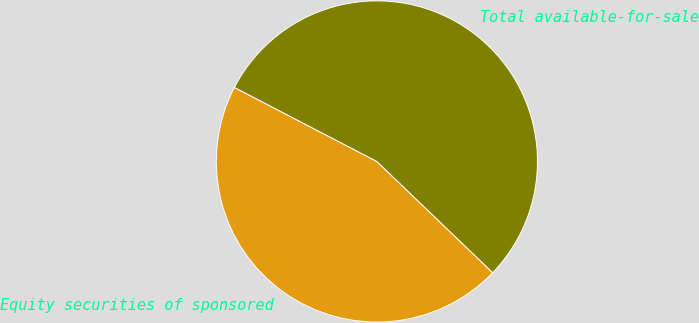<chart> <loc_0><loc_0><loc_500><loc_500><pie_chart><fcel>Equity securities of sponsored<fcel>Total available-for-sale<nl><fcel>45.45%<fcel>54.55%<nl></chart> 